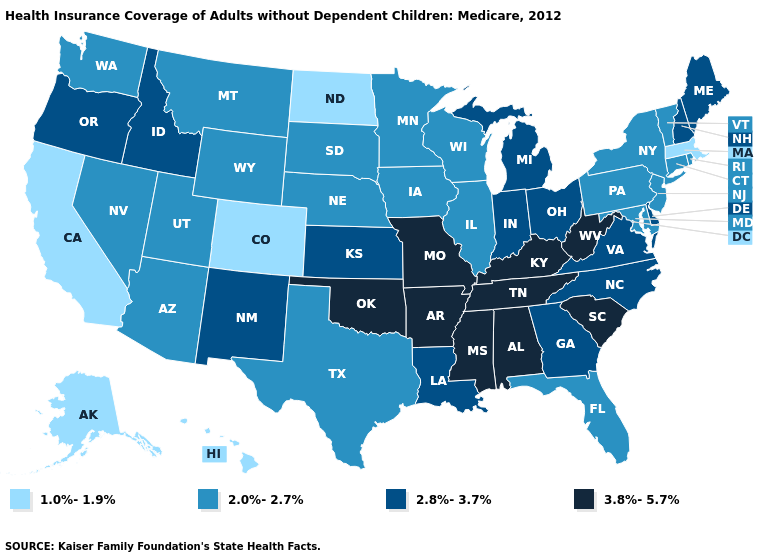What is the highest value in the USA?
Short answer required. 3.8%-5.7%. Among the states that border Kentucky , which have the lowest value?
Quick response, please. Illinois. Name the states that have a value in the range 1.0%-1.9%?
Short answer required. Alaska, California, Colorado, Hawaii, Massachusetts, North Dakota. Which states have the highest value in the USA?
Be succinct. Alabama, Arkansas, Kentucky, Mississippi, Missouri, Oklahoma, South Carolina, Tennessee, West Virginia. What is the value of North Dakota?
Short answer required. 1.0%-1.9%. What is the value of Washington?
Be succinct. 2.0%-2.7%. What is the value of Minnesota?
Be succinct. 2.0%-2.7%. What is the value of New Hampshire?
Give a very brief answer. 2.8%-3.7%. Name the states that have a value in the range 2.0%-2.7%?
Keep it brief. Arizona, Connecticut, Florida, Illinois, Iowa, Maryland, Minnesota, Montana, Nebraska, Nevada, New Jersey, New York, Pennsylvania, Rhode Island, South Dakota, Texas, Utah, Vermont, Washington, Wisconsin, Wyoming. Does the first symbol in the legend represent the smallest category?
Short answer required. Yes. What is the value of Michigan?
Give a very brief answer. 2.8%-3.7%. Name the states that have a value in the range 2.8%-3.7%?
Answer briefly. Delaware, Georgia, Idaho, Indiana, Kansas, Louisiana, Maine, Michigan, New Hampshire, New Mexico, North Carolina, Ohio, Oregon, Virginia. Name the states that have a value in the range 2.0%-2.7%?
Concise answer only. Arizona, Connecticut, Florida, Illinois, Iowa, Maryland, Minnesota, Montana, Nebraska, Nevada, New Jersey, New York, Pennsylvania, Rhode Island, South Dakota, Texas, Utah, Vermont, Washington, Wisconsin, Wyoming. Does Colorado have the highest value in the USA?
Write a very short answer. No. Among the states that border Montana , which have the lowest value?
Answer briefly. North Dakota. 